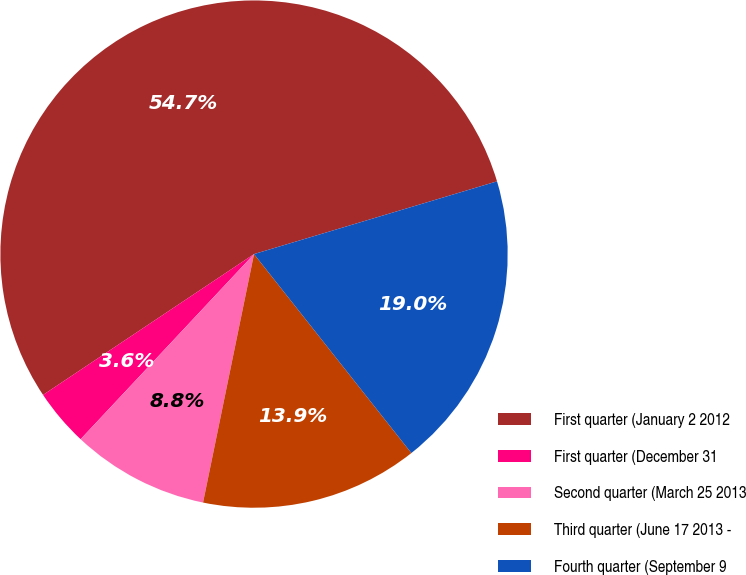Convert chart. <chart><loc_0><loc_0><loc_500><loc_500><pie_chart><fcel>First quarter (January 2 2012<fcel>First quarter (December 31<fcel>Second quarter (March 25 2013<fcel>Third quarter (June 17 2013 -<fcel>Fourth quarter (September 9<nl><fcel>54.74%<fcel>3.65%<fcel>8.76%<fcel>13.87%<fcel>18.98%<nl></chart> 